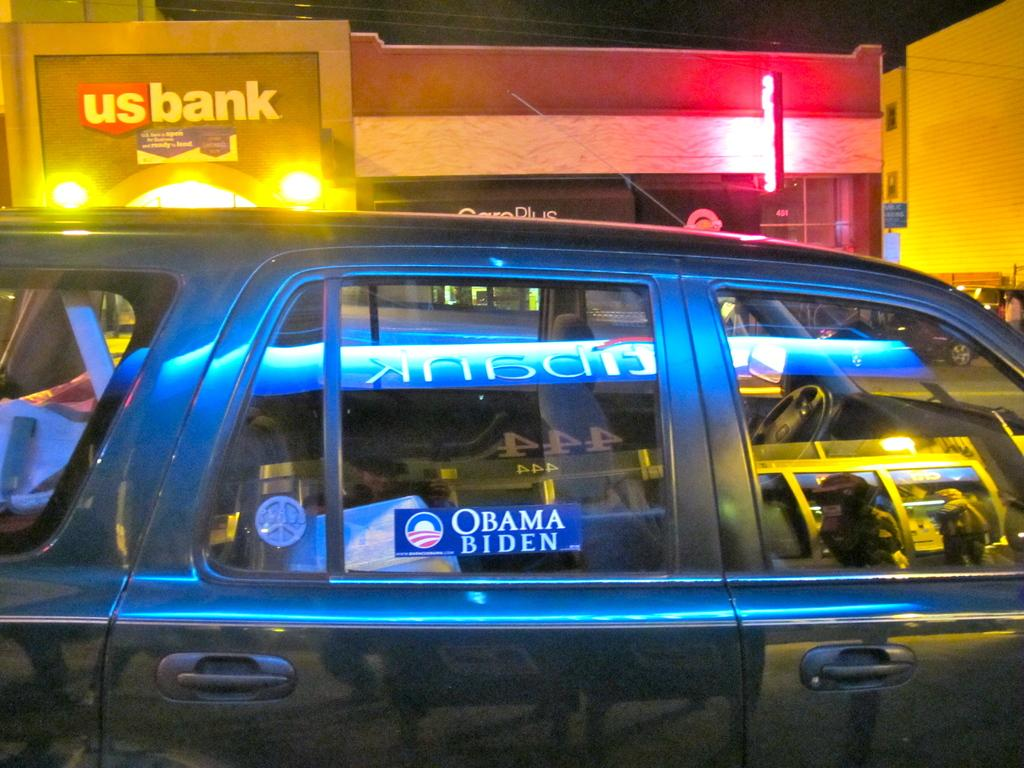<image>
Create a compact narrative representing the image presented. A peace loving Democrat is parked near a US Bank. 